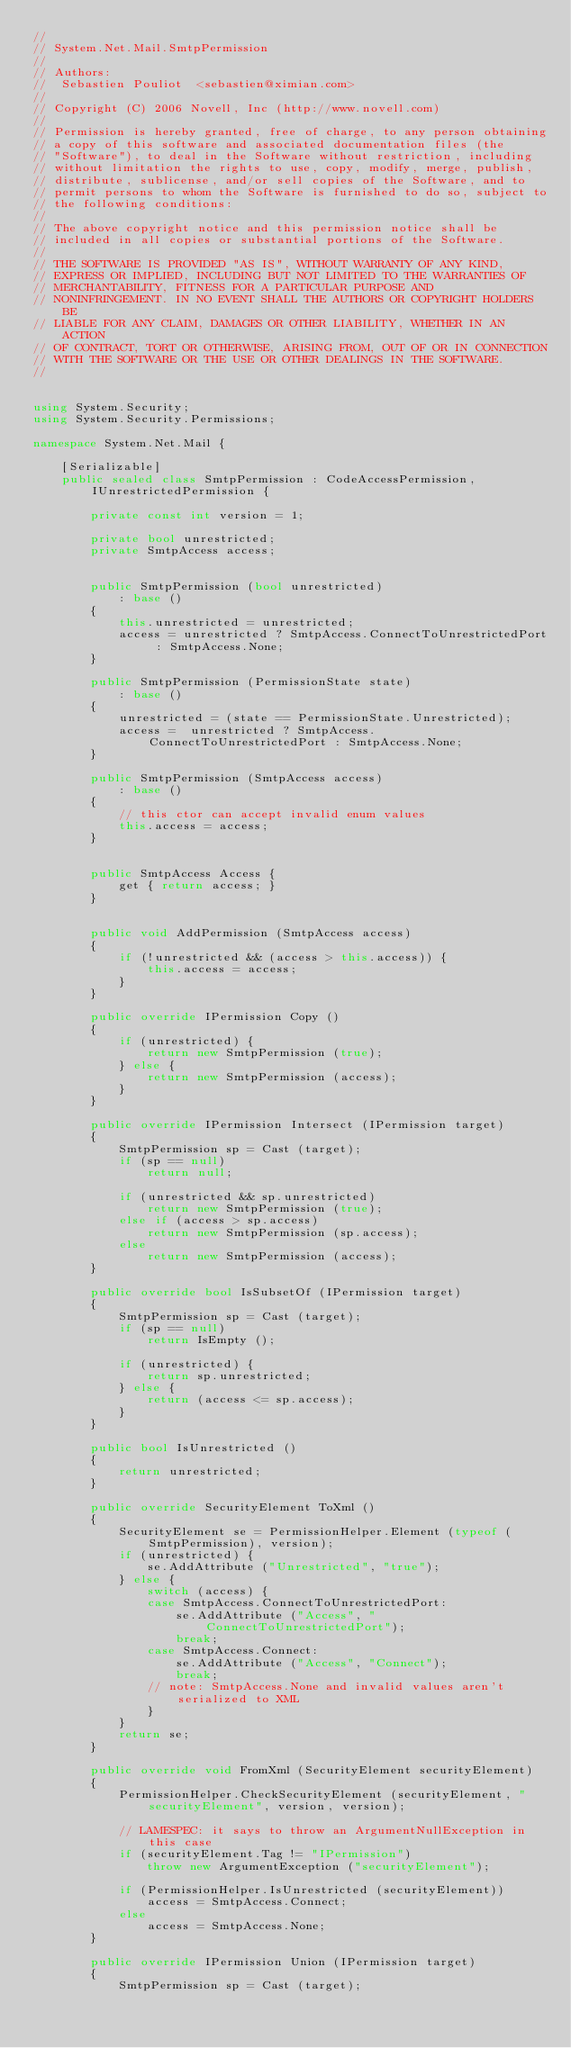<code> <loc_0><loc_0><loc_500><loc_500><_C#_>//
// System.Net.Mail.SmtpPermission
//
// Authors:
//	Sebastien Pouliot  <sebastien@ximian.com>
//
// Copyright (C) 2006 Novell, Inc (http://www.novell.com)
//
// Permission is hereby granted, free of charge, to any person obtaining
// a copy of this software and associated documentation files (the
// "Software"), to deal in the Software without restriction, including
// without limitation the rights to use, copy, modify, merge, publish,
// distribute, sublicense, and/or sell copies of the Software, and to
// permit persons to whom the Software is furnished to do so, subject to
// the following conditions:
// 
// The above copyright notice and this permission notice shall be
// included in all copies or substantial portions of the Software.
// 
// THE SOFTWARE IS PROVIDED "AS IS", WITHOUT WARRANTY OF ANY KIND,
// EXPRESS OR IMPLIED, INCLUDING BUT NOT LIMITED TO THE WARRANTIES OF
// MERCHANTABILITY, FITNESS FOR A PARTICULAR PURPOSE AND
// NONINFRINGEMENT. IN NO EVENT SHALL THE AUTHORS OR COPYRIGHT HOLDERS BE
// LIABLE FOR ANY CLAIM, DAMAGES OR OTHER LIABILITY, WHETHER IN AN ACTION
// OF CONTRACT, TORT OR OTHERWISE, ARISING FROM, OUT OF OR IN CONNECTION
// WITH THE SOFTWARE OR THE USE OR OTHER DEALINGS IN THE SOFTWARE.
//


using System.Security;
using System.Security.Permissions;

namespace System.Net.Mail {

	[Serializable]
	public sealed class SmtpPermission : CodeAccessPermission, IUnrestrictedPermission {

		private const int version = 1;

		private bool unrestricted;
		private SmtpAccess access;


		public SmtpPermission (bool unrestricted)
			: base ()
		{
			this.unrestricted = unrestricted;
			access = unrestricted ? SmtpAccess.ConnectToUnrestrictedPort : SmtpAccess.None;
		}

		public SmtpPermission (PermissionState state)
			: base ()
		{
			unrestricted = (state == PermissionState.Unrestricted);
			access =  unrestricted ? SmtpAccess.ConnectToUnrestrictedPort : SmtpAccess.None;
		}

		public SmtpPermission (SmtpAccess access)
			: base ()
		{
			// this ctor can accept invalid enum values
			this.access = access;
		}
		

		public SmtpAccess Access {
			get { return access; }
		}


		public void AddPermission (SmtpAccess access)
		{
			if (!unrestricted && (access > this.access)) {
				this.access = access;
			}
		}

		public override IPermission Copy ()
		{
			if (unrestricted) {
				return new SmtpPermission (true);
			} else {
				return new SmtpPermission (access);
			}
		}

		public override IPermission Intersect (IPermission target)
		{
			SmtpPermission sp = Cast (target);
			if (sp == null)
				return null;

			if (unrestricted && sp.unrestricted)
				return new SmtpPermission (true);
			else if (access > sp.access)
				return new SmtpPermission (sp.access);
			else
				return new SmtpPermission (access);
		}
		
		public override bool IsSubsetOf (IPermission target) 
		{
			SmtpPermission sp = Cast (target);
			if (sp == null)
				return IsEmpty ();

			if (unrestricted) {
				return sp.unrestricted;
			} else {
				return (access <= sp.access);
			}
		}

		public bool IsUnrestricted () 
		{
			return unrestricted;
		}

		public override SecurityElement ToXml ()
		{
			SecurityElement se = PermissionHelper.Element (typeof (SmtpPermission), version);
			if (unrestricted) {
				se.AddAttribute ("Unrestricted", "true");
			} else {
				switch (access) {
				case SmtpAccess.ConnectToUnrestrictedPort:
					se.AddAttribute ("Access", "ConnectToUnrestrictedPort");
					break;
				case SmtpAccess.Connect:
					se.AddAttribute ("Access", "Connect");
					break;
				// note: SmtpAccess.None and invalid values aren't serialized to XML
				}
			}
			return se;
		}
		
		public override void FromXml (SecurityElement securityElement)
		{
			PermissionHelper.CheckSecurityElement (securityElement, "securityElement", version, version);
		
			// LAMESPEC: it says to throw an ArgumentNullException in this case				
			if (securityElement.Tag != "IPermission")
				throw new ArgumentException ("securityElement");
				
			if (PermissionHelper.IsUnrestricted (securityElement))
				access = SmtpAccess.Connect;
			else
				access = SmtpAccess.None;
		}		
		
		public override IPermission Union (IPermission target) 
		{
			SmtpPermission sp = Cast (target);</code> 